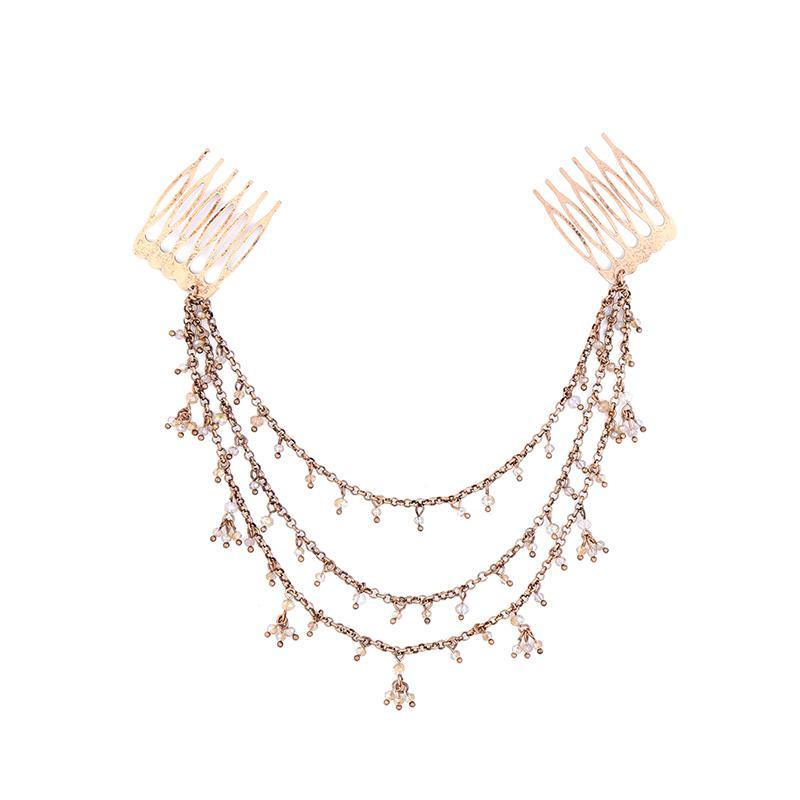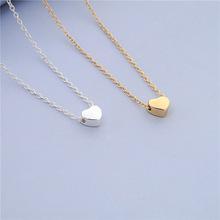The first image is the image on the left, the second image is the image on the right. For the images displayed, is the sentence "Both images contain safety pins." factually correct? Answer yes or no. No. 